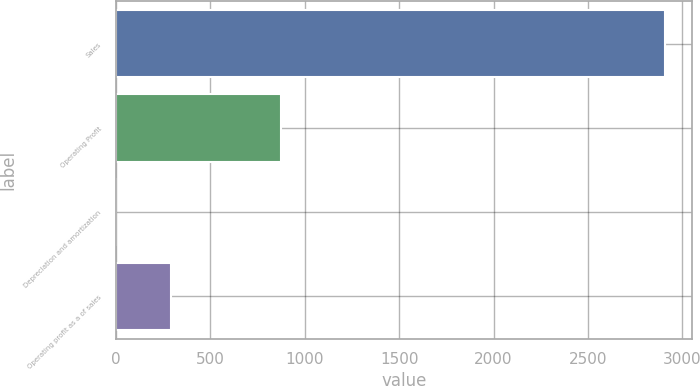Convert chart to OTSL. <chart><loc_0><loc_0><loc_500><loc_500><bar_chart><fcel>Sales<fcel>Operating Profit<fcel>Depreciation and amortization<fcel>Operating profit as a of sales<nl><fcel>2906.5<fcel>873.14<fcel>1.7<fcel>292.18<nl></chart> 